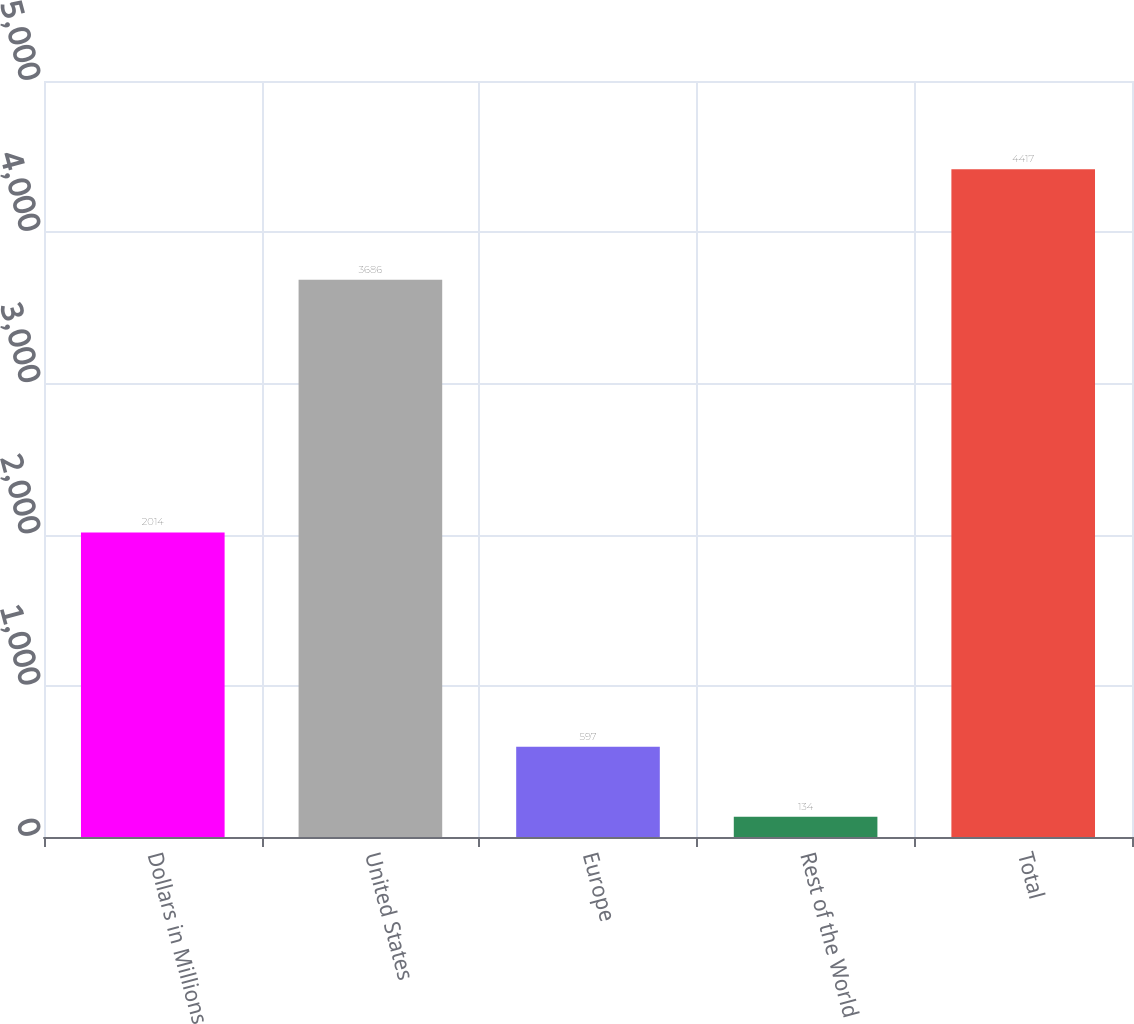Convert chart to OTSL. <chart><loc_0><loc_0><loc_500><loc_500><bar_chart><fcel>Dollars in Millions<fcel>United States<fcel>Europe<fcel>Rest of the World<fcel>Total<nl><fcel>2014<fcel>3686<fcel>597<fcel>134<fcel>4417<nl></chart> 